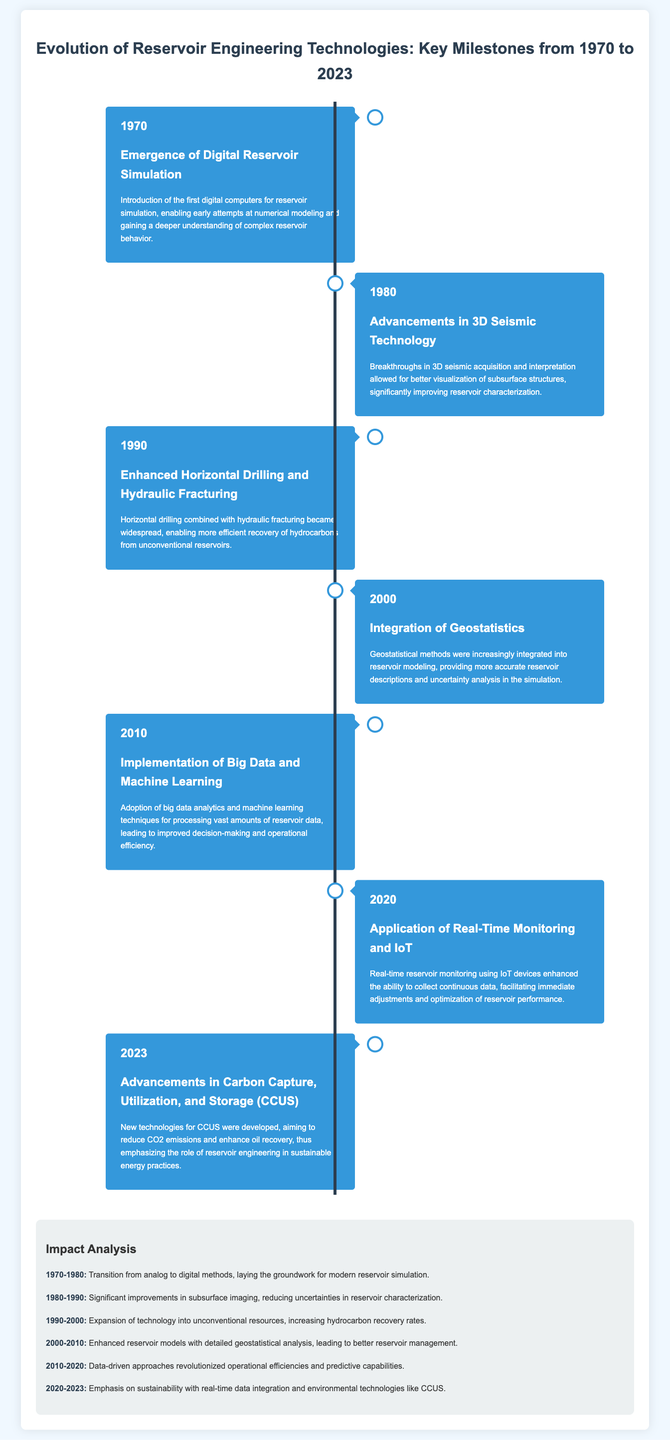What year did digital reservoir simulation emerge? The document states that the emergence of digital reservoir simulation occurred in 1970.
Answer: 1970 What technology breakthrough occurred in 1980? According to the document, advancements in 3D seismic technology were achieved in 1980.
Answer: 3D seismic technology What significant practice was widely adopted in 1990? The document mentions that enhanced horizontal drilling and hydraulic fracturing became widespread in 1990.
Answer: Horizontal drilling and hydraulic fracturing Which new method was integrated into reservoir modeling in 2000? The integration of geostatistics into reservoir modeling is noted in the document as occurring in 2000.
Answer: Geostatistics What major technologies were implemented in 2010? The document highlights the implementation of big data and machine learning technologies in 2010.
Answer: Big data and machine learning What does the timeline highlight for the period 2020-2023? The document emphasizes advances in carbon capture, utilization, and storage for the period 2020-2023.
Answer: Carbon capture, utilization, and storage How did the technology transition from 1970-1980 impact reservoir engineering? The impact analysis section specifies that the transition laid groundwork for modern reservoir simulation.
Answer: Groundwork for modern simulation In which decade did data-driven approaches emerge? The document indicates that data-driven approaches emerged significantly between 2010 and 2020.
Answer: 2010-2020 